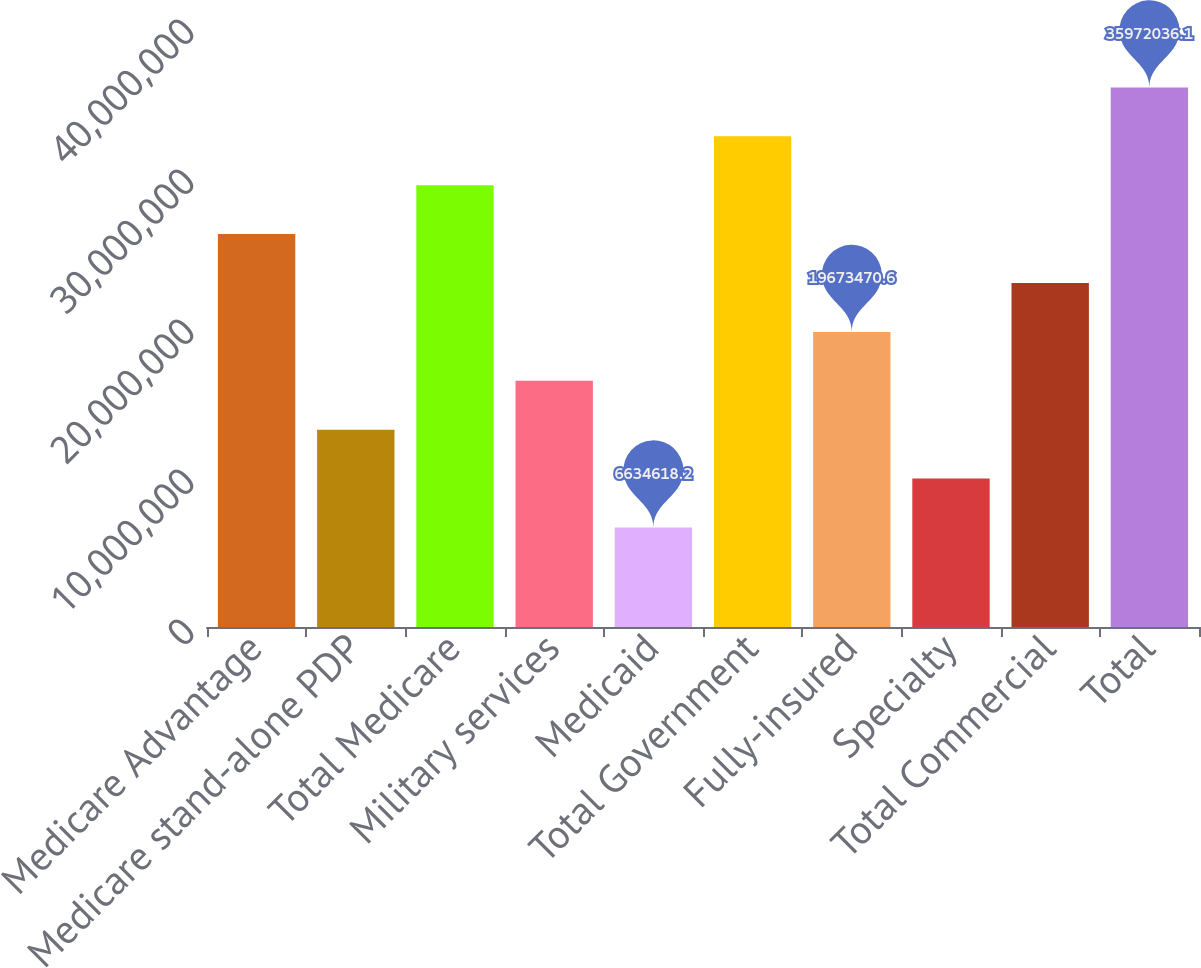Convert chart. <chart><loc_0><loc_0><loc_500><loc_500><bar_chart><fcel>Medicare Advantage<fcel>Medicare stand-alone PDP<fcel>Total Medicare<fcel>Military services<fcel>Medicaid<fcel>Total Government<fcel>Fully-insured<fcel>Specialty<fcel>Total Commercial<fcel>Total<nl><fcel>2.61929e+07<fcel>1.3154e+07<fcel>2.94526e+07<fcel>1.64138e+07<fcel>6.63462e+06<fcel>3.27123e+07<fcel>1.96735e+07<fcel>9.89433e+06<fcel>2.29332e+07<fcel>3.5972e+07<nl></chart> 